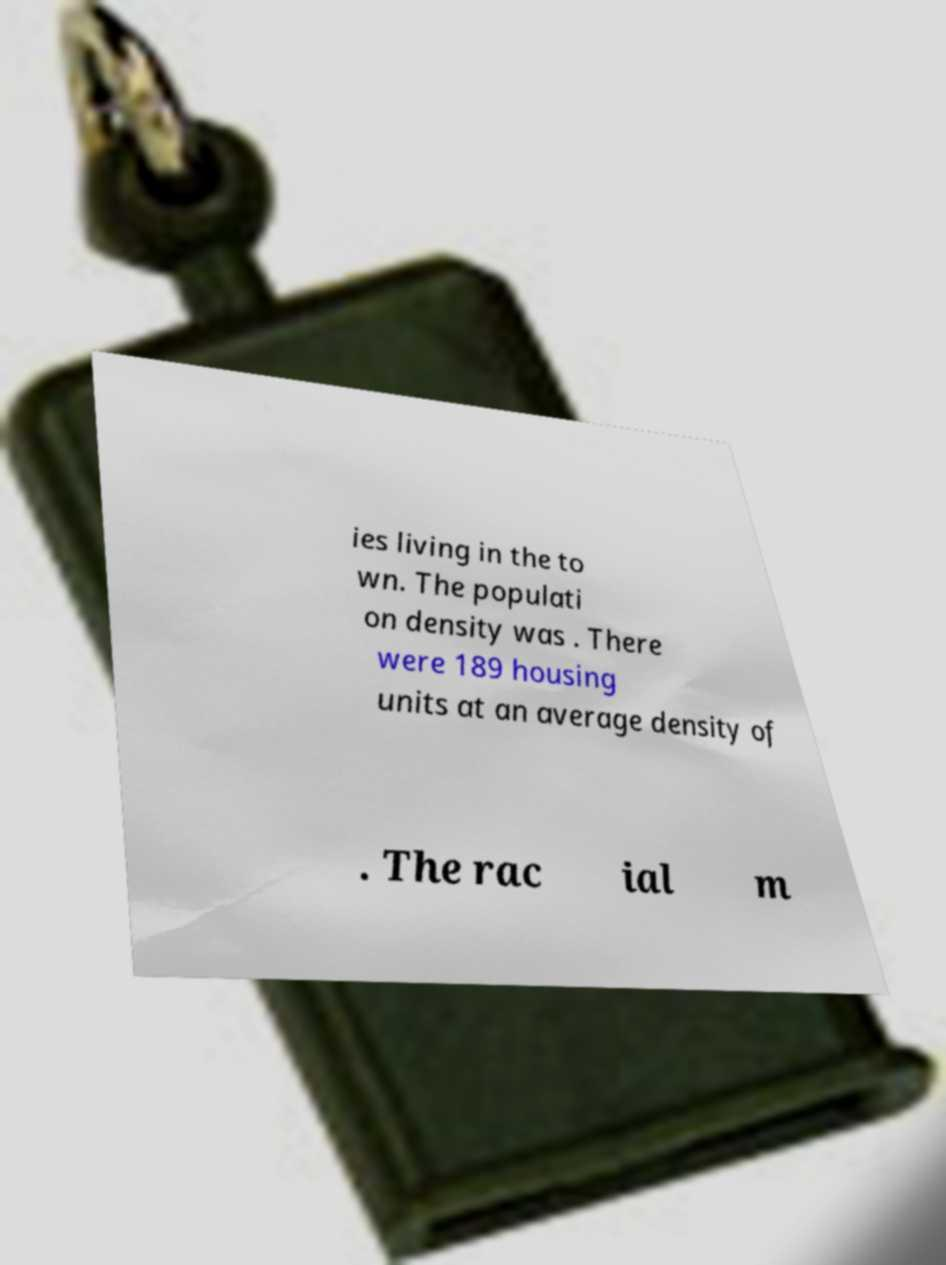Can you read and provide the text displayed in the image?This photo seems to have some interesting text. Can you extract and type it out for me? ies living in the to wn. The populati on density was . There were 189 housing units at an average density of . The rac ial m 